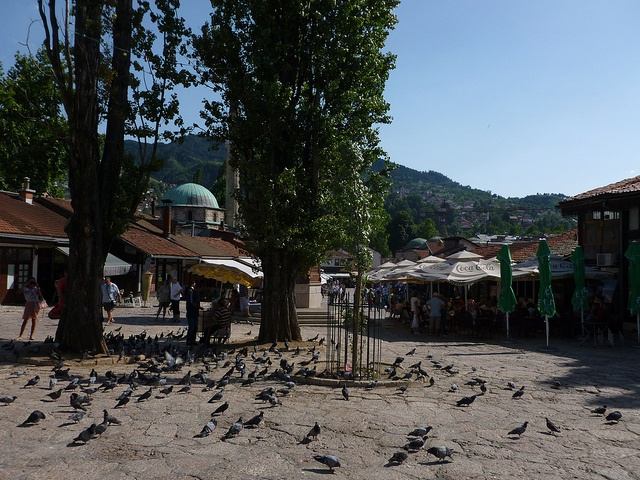Describe the objects in this image and their specific colors. I can see bird in gray and black tones, umbrella in gray, black, darkgreen, and darkgray tones, umbrella in gray, black, darkgreen, teal, and purple tones, umbrella in gray, maroon, black, and olive tones, and people in gray, black, and maroon tones in this image. 